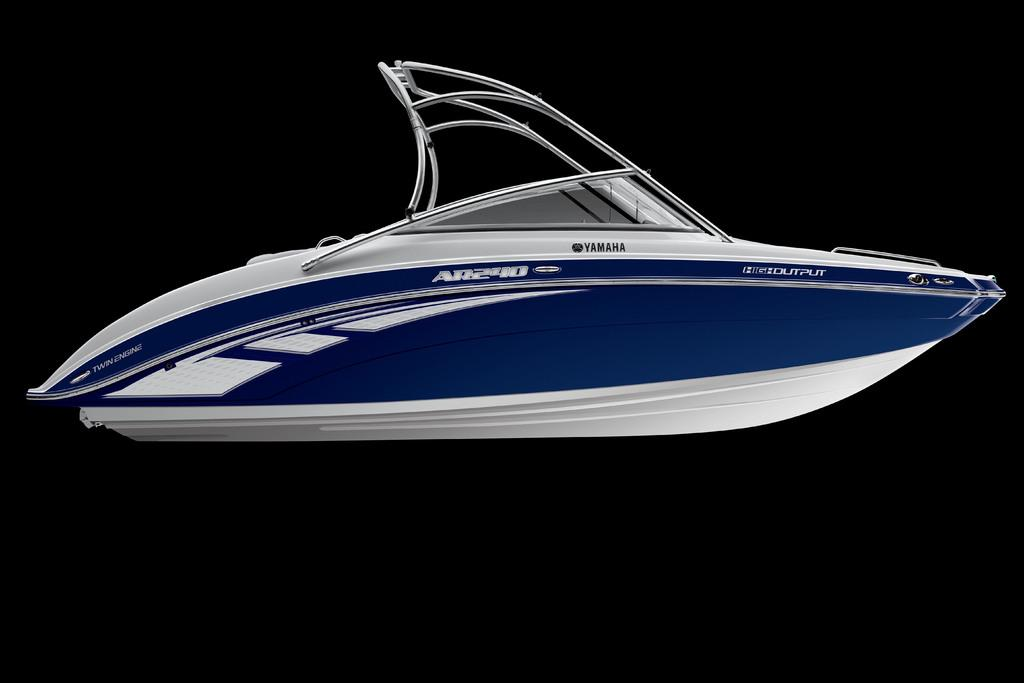What is the main subject of the image? The main subject of the image is a motor boat. Can you describe the color of the motor boat? The motor boat is blue and white in color. What else can be seen on the motor boat? There is text on the motor boat. What is the general appearance of the background in the image? The background of the image is dark. Can you tell if there is an argument happening between the people on the motor boat? There is no indication of an argument or any people in the image; it only features a motor boat with text on it. What type of badge is visible on the motor boat? There is no badge present on the motor boat in the image. 